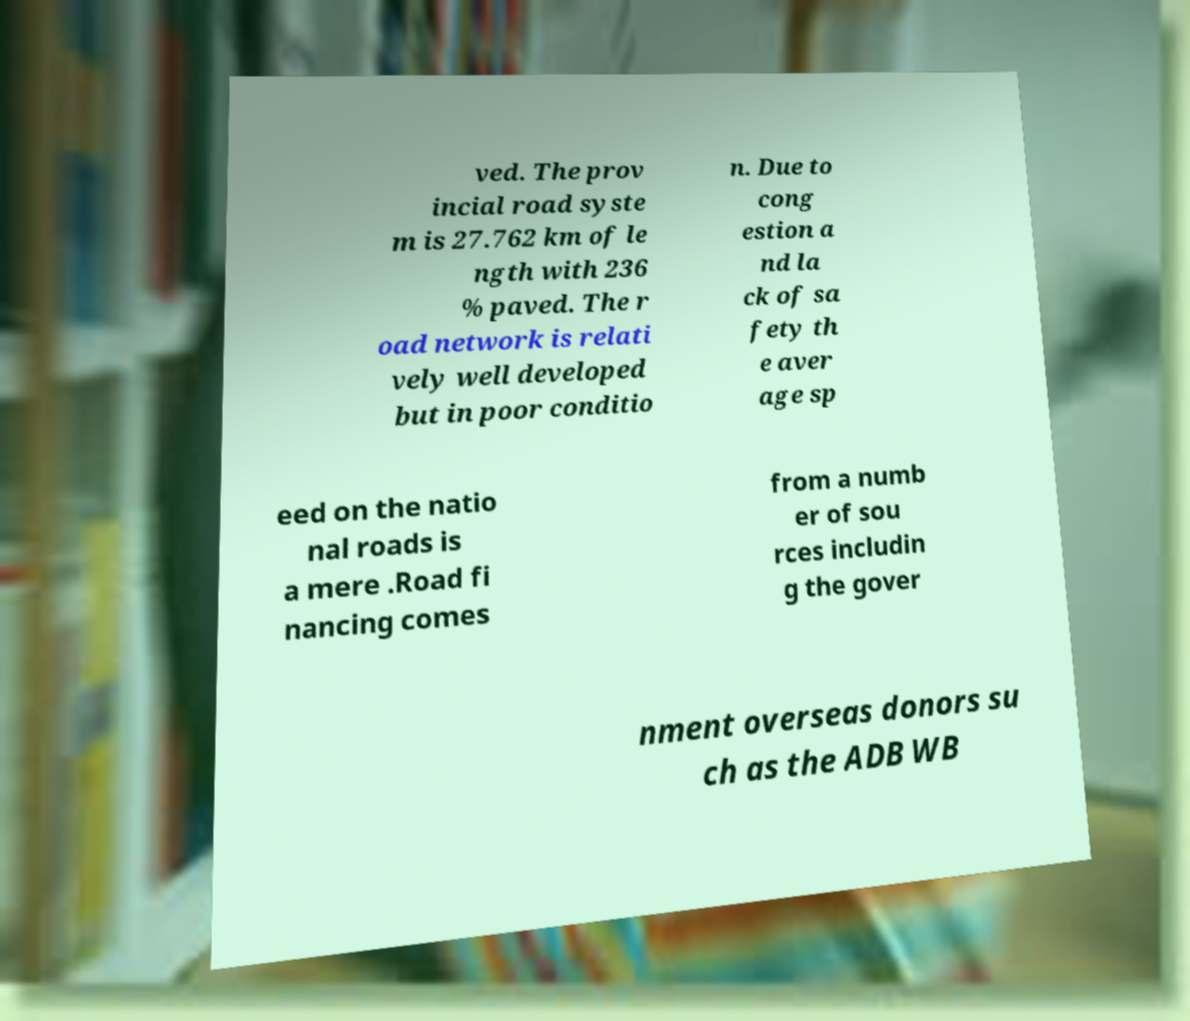Please identify and transcribe the text found in this image. ved. The prov incial road syste m is 27.762 km of le ngth with 236 % paved. The r oad network is relati vely well developed but in poor conditio n. Due to cong estion a nd la ck of sa fety th e aver age sp eed on the natio nal roads is a mere .Road fi nancing comes from a numb er of sou rces includin g the gover nment overseas donors su ch as the ADB WB 